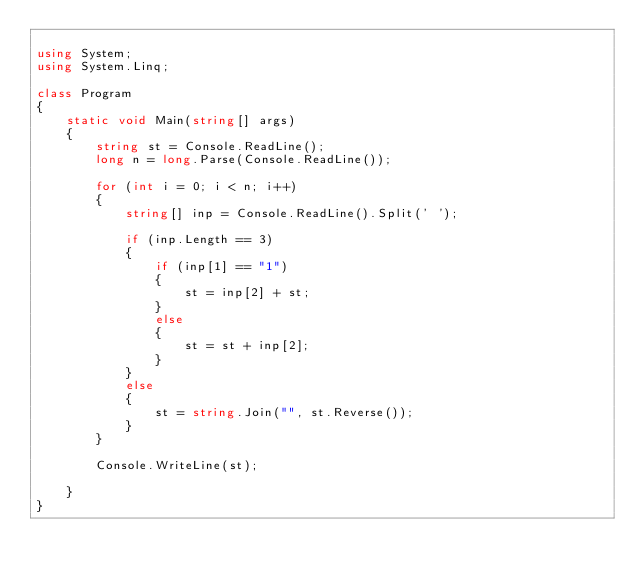<code> <loc_0><loc_0><loc_500><loc_500><_C#_>
using System;
using System.Linq;

class Program
{
    static void Main(string[] args)
    {
        string st = Console.ReadLine();
        long n = long.Parse(Console.ReadLine());

        for (int i = 0; i < n; i++)
        {
            string[] inp = Console.ReadLine().Split(' ');

            if (inp.Length == 3)
            {
                if (inp[1] == "1")
                {
                    st = inp[2] + st;
                }
                else
                {
                    st = st + inp[2];
                }
            }
            else
            {
                st = string.Join("", st.Reverse());
            }
        }

        Console.WriteLine(st);

    }
}
</code> 